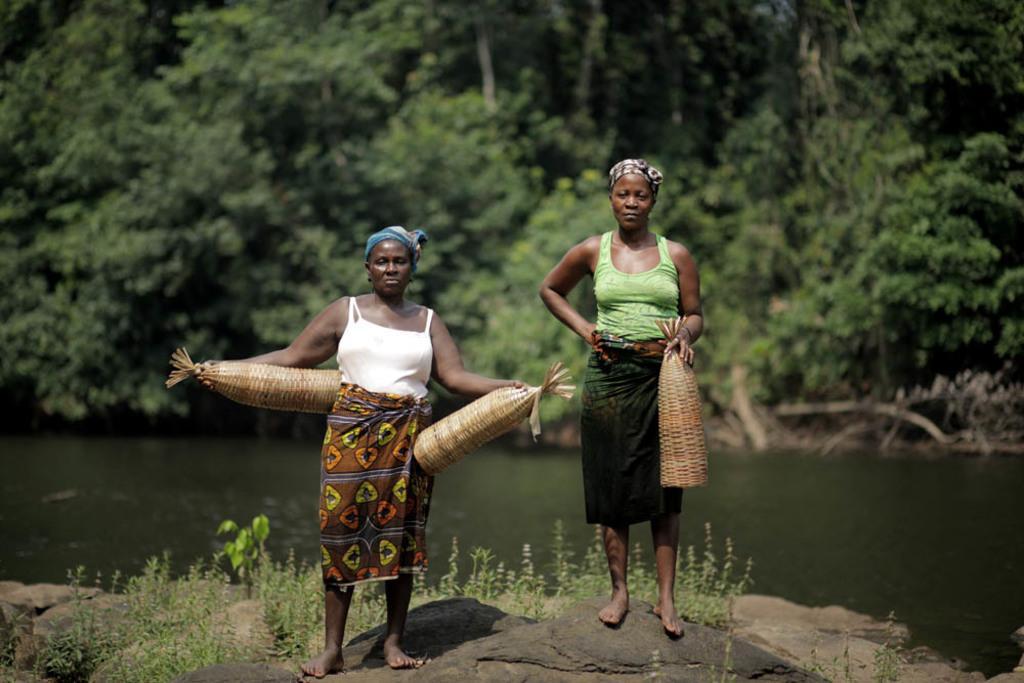How would you summarize this image in a sentence or two? In the center of the image we can see two persons standing on the stone. In the background we can see water, trees and plants. 